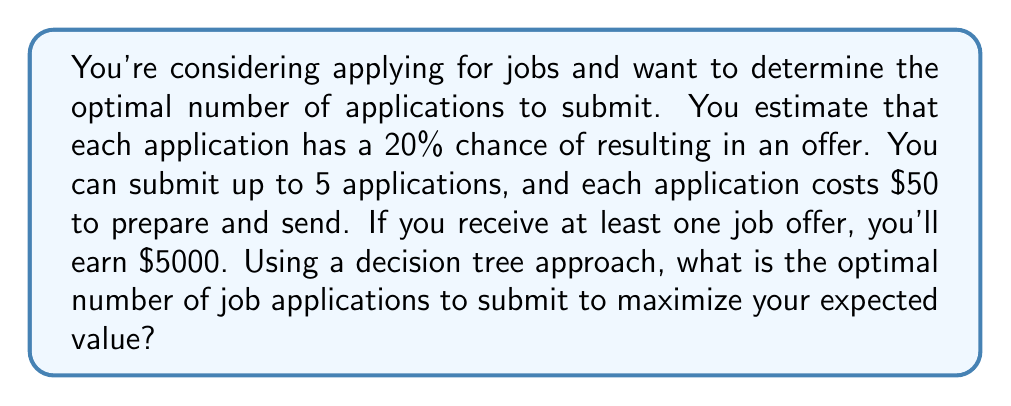Can you answer this question? Let's approach this problem step-by-step using a decision tree:

1) First, we need to calculate the probability of getting at least one offer for each number of applications:

   For 1 application: $P(1) = 0.2$
   For 2 applications: $P(2) = 1 - (0.8)^2 = 0.36$
   For 3 applications: $P(3) = 1 - (0.8)^3 = 0.488$
   For 4 applications: $P(4) = 1 - (0.8)^4 = 0.5904$
   For 5 applications: $P(5) = 1 - (0.8)^5 = 0.67232$

2) Now, let's calculate the expected value for each number of applications:

   $EV(n) = 5000 * P(n) - 50n$

   Where $n$ is the number of applications.

3) Let's calculate the expected value for each case:

   $EV(1) = 5000 * 0.2 - 50 * 1 = 950$
   $EV(2) = 5000 * 0.36 - 50 * 2 = 1700$
   $EV(3) = 5000 * 0.488 - 50 * 3 = 2290$
   $EV(4) = 5000 * 0.5904 - 50 * 4 = 2752$
   $EV(5) = 5000 * 0.67232 - 50 * 5 = 3111.6$

4) The decision tree would look like this:

   [asy]
   import geometry;

   void drawNode(pair p, string s) {
     dot(p);
     label(s, p, E);
   }

   pair origin = (0,0);
   drawNode(origin, "Start");

   for (int i = 1; i <= 5; ++i) {
     pair p = origin - (0, i*20);
     draw(origin--p);
     drawNode(p, format("%d app: $%0.2f", i, 5000*(1-(0.8)^i)-50*i));
   }
   [/asy]

5) From the decision tree, we can see that the expected value increases with each additional application up to 5 applications.
Answer: The optimal number of job applications to submit is 5, which yields the highest expected value of $3111.60. 